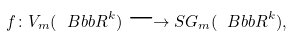Convert formula to latex. <formula><loc_0><loc_0><loc_500><loc_500>f \colon V _ { m } ( { \ B b b R } ^ { k } ) \longrightarrow S G _ { m } ( { \ B b b R } ^ { k } ) ,</formula> 